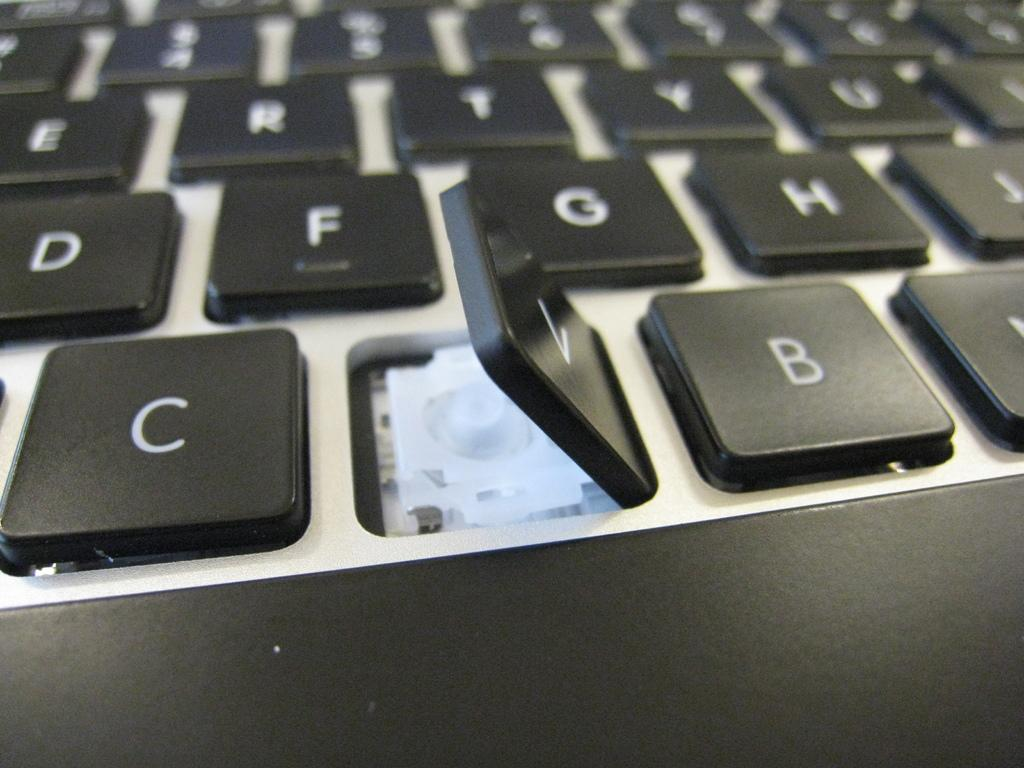Provide a one-sentence caption for the provided image. A computer keyboard, with the letter V key raised up. 